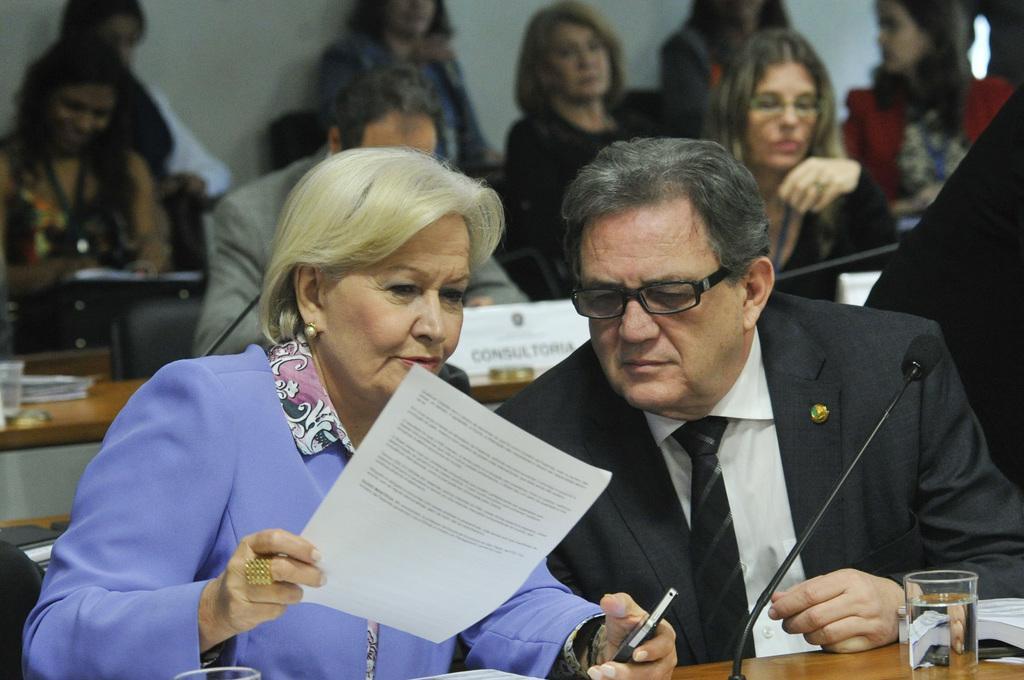Please provide a concise description of this image. In this image on the right, there is a man, he wears a suit, shirt and there is a woman, she wears a suit, shirt, she is holding a paper and mobile, in front of them there is a table on that there are papers, books, glasses, mic. In the background there are many people, tables, chairs, glasses, posters and wall. 